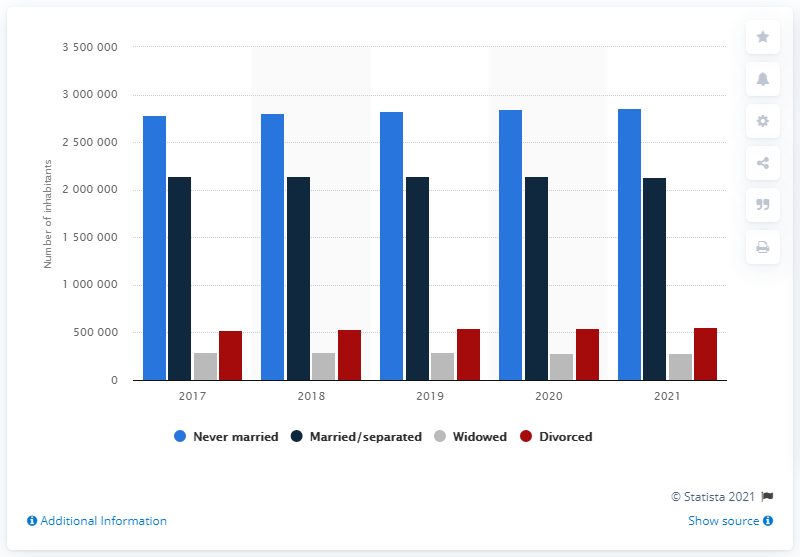List a handful of essential elements in this visual. As of January 1, 2021, it is estimated that 213,6102 people in Denmark were either married or separated. As of January 1, 2021, approximately 281,118 people in Denmark had never been married. A total of 287,344 people were widowed in the given year. 